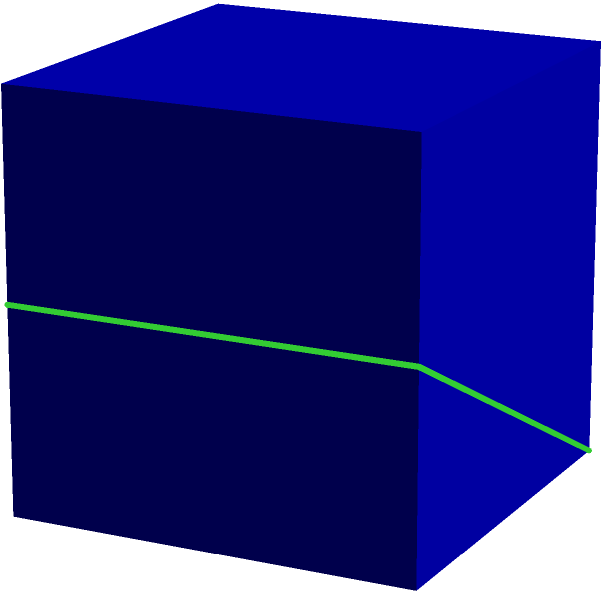Imagine you're helping your child understand geometry for their rehabilitation program. Consider a cube being cut by a plane passing through three points: (0,0,0), (1,1,0.5), and (1,0,0.5). What shape is formed by the intersection of this plane and the cube? Let's approach this step-by-step:

1) First, visualize the cube. It has 6 square faces, 8 vertices, and 12 edges.

2) Now, consider the plane cutting through the cube. It passes through three points:
   - (0,0,0): One corner of the cube
   - (1,1,0.5): A point halfway up the opposite diagonal edge
   - (1,0,0.5): A point halfway up one of the vertical edges

3) This plane cuts through:
   - The bottom face of the cube (at point (0,0,0))
   - Two adjacent vertical faces
   - The top face of the cube

4) The intersection of this plane with each face of the cube forms a line segment.

5) Connecting these line segments, we get a closed shape on the plane.

6) Looking closely, we can see that this shape has four sides:
   - One side from the bottom face to the front face
   - One side along the front face
   - One side from the front face to the top face
   - One side from the top face back to the bottom face

7) A closed shape with four sides is a quadrilateral.

8) However, this is not just any quadrilateral. The sides are not all equal, and the angles are not all right angles. This makes it an irregular quadrilateral.
Answer: Irregular quadrilateral 